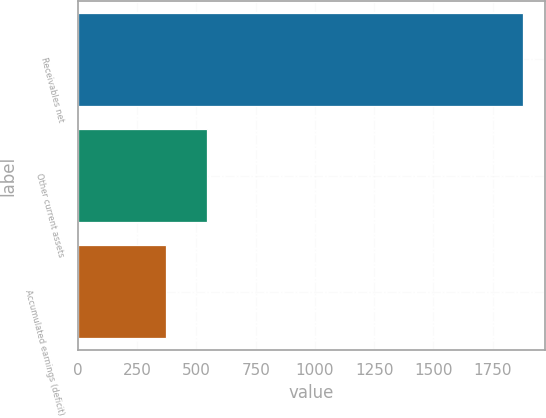Convert chart. <chart><loc_0><loc_0><loc_500><loc_500><bar_chart><fcel>Receivables net<fcel>Other current assets<fcel>Accumulated earnings (deficit)<nl><fcel>1877<fcel>543<fcel>372<nl></chart> 